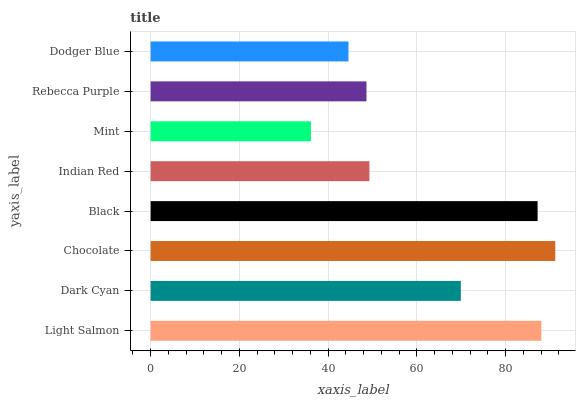Is Mint the minimum?
Answer yes or no. Yes. Is Chocolate the maximum?
Answer yes or no. Yes. Is Dark Cyan the minimum?
Answer yes or no. No. Is Dark Cyan the maximum?
Answer yes or no. No. Is Light Salmon greater than Dark Cyan?
Answer yes or no. Yes. Is Dark Cyan less than Light Salmon?
Answer yes or no. Yes. Is Dark Cyan greater than Light Salmon?
Answer yes or no. No. Is Light Salmon less than Dark Cyan?
Answer yes or no. No. Is Dark Cyan the high median?
Answer yes or no. Yes. Is Indian Red the low median?
Answer yes or no. Yes. Is Dodger Blue the high median?
Answer yes or no. No. Is Rebecca Purple the low median?
Answer yes or no. No. 